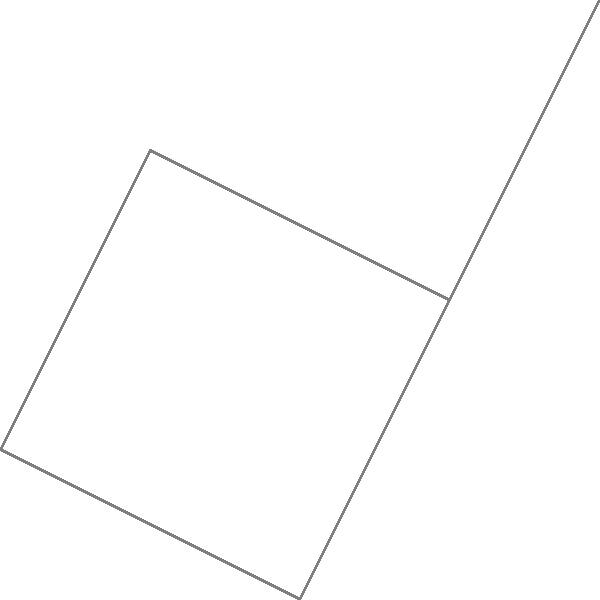As a costume designer familiar with interpreting movement and form, analyze the star chart above. If the stars were to represent dancers in various positions, which connecting line would best represent the flow of a waltz-like movement in this constellation? To answer this question, let's approach it step-by-step, considering the characteristics of waltz movement and how they might be represented in the star chart:

1. Waltz is known for its smooth, flowing, and circular movements.
2. In the star chart, we need to look for a path that suggests a curved or circular motion.
3. Examining the connecting lines between the stars:
   - A-B-C forms a sharp angle, not suitable for a smooth waltz movement.
   - C-D-E also forms relatively sharp angles.
   - E-A-B creates a smoother curve.
   - B-C-D forms another relatively smooth curve.
4. The line E-A-B-C forms the most continuous curved path in the constellation.
5. This curved path E-A-B-C could represent the characteristic rise and fall motion of a waltz, with:
   - E as the lowest point (preparation)
   - A as the rising motion
   - B as the highest point (the '1' count in waltz timing)
   - C as the gradual lowering

The E-A-B-C path best emulates the flowing, circular nature of a waltz-like movement among the stars in this constellation.
Answer: E-A-B-C 